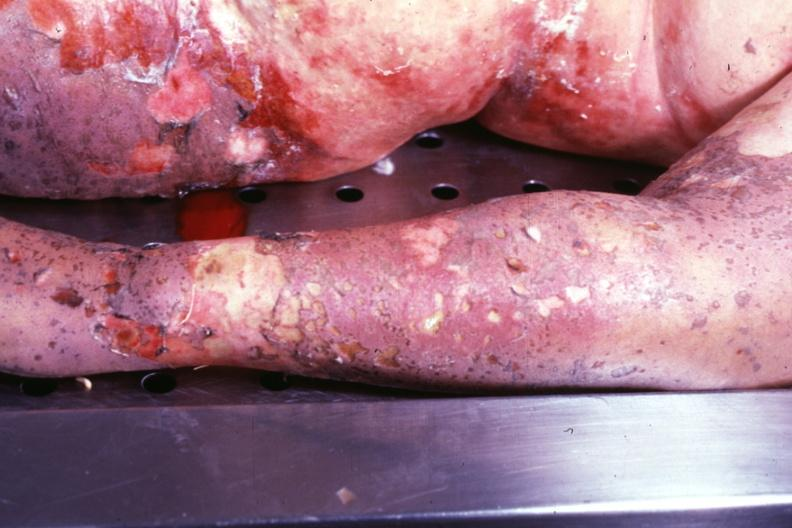what is present?
Answer the question using a single word or phrase. Toxic epidermal necrolysis 